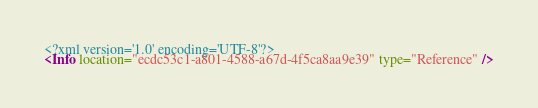Convert code to text. <code><loc_0><loc_0><loc_500><loc_500><_XML_><?xml version='1.0' encoding='UTF-8'?>
<Info location="ecdc53c1-a801-4588-a67d-4f5ca8aa9e39" type="Reference" /></code> 